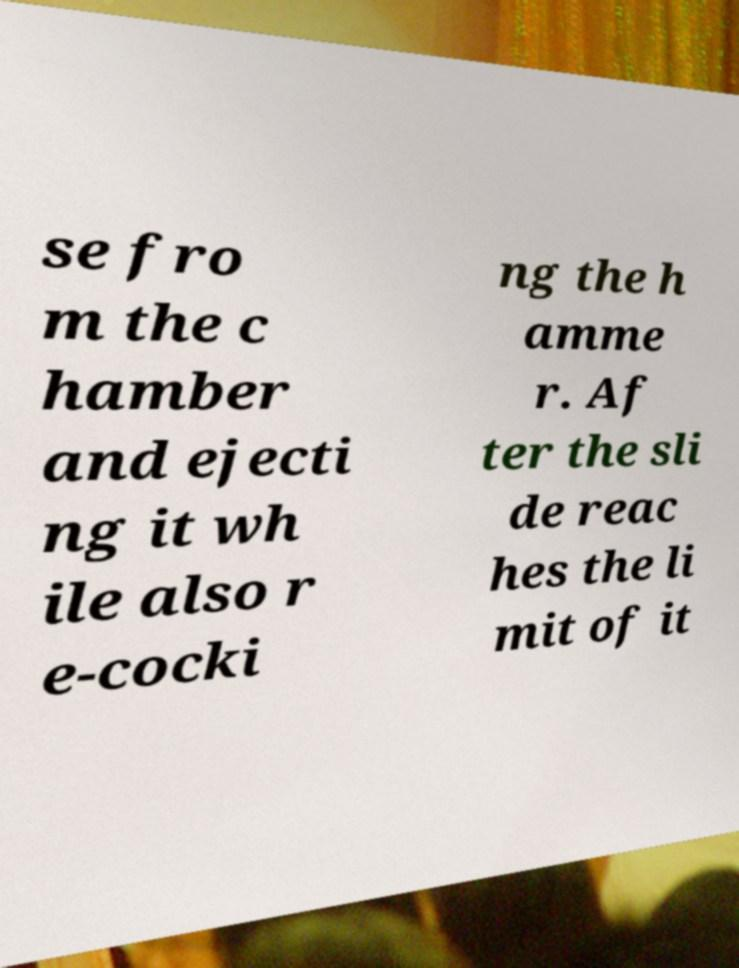Please read and relay the text visible in this image. What does it say? se fro m the c hamber and ejecti ng it wh ile also r e-cocki ng the h amme r. Af ter the sli de reac hes the li mit of it 